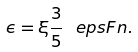Convert formula to latex. <formula><loc_0><loc_0><loc_500><loc_500>\epsilon = \xi \frac { 3 } { 5 } \ e p s F n .</formula> 